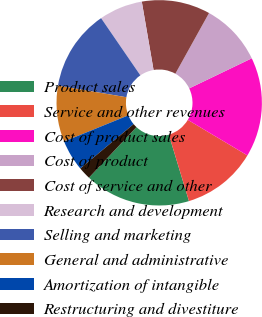Convert chart to OTSL. <chart><loc_0><loc_0><loc_500><loc_500><pie_chart><fcel>Product sales<fcel>Service and other revenues<fcel>Cost of product sales<fcel>Cost of product<fcel>Cost of service and other<fcel>Research and development<fcel>Selling and marketing<fcel>General and administrative<fcel>Amortization of intangible<fcel>Restructuring and divestiture<nl><fcel>16.67%<fcel>11.76%<fcel>15.69%<fcel>9.8%<fcel>10.78%<fcel>6.86%<fcel>12.75%<fcel>8.82%<fcel>4.9%<fcel>1.96%<nl></chart> 